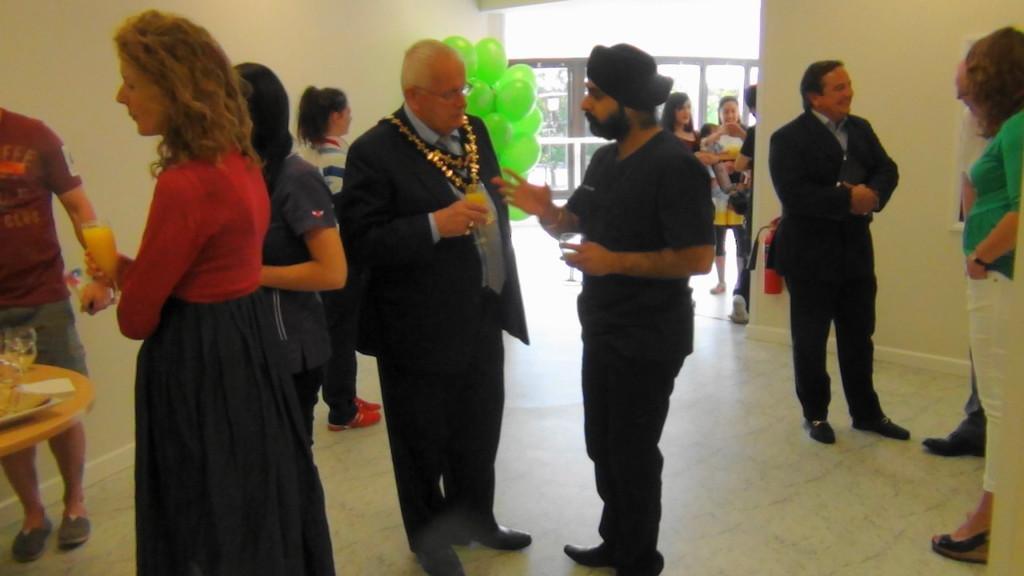Can you describe this image briefly? This picture is taken in a room. In the room, there are people in the center. In the center, there is a man wearing a blazer, trousers and holding a glass. Before him, there is another man wearing black clothes and holding a glass. Behind them, there are green balloons. Towards the left there is a woman wearing a red top, black skirt and holding a glass. Towards the left corner, there is a table. On the table, there are glasses. Towards the right, there are people. In the background, there are people and trees. 